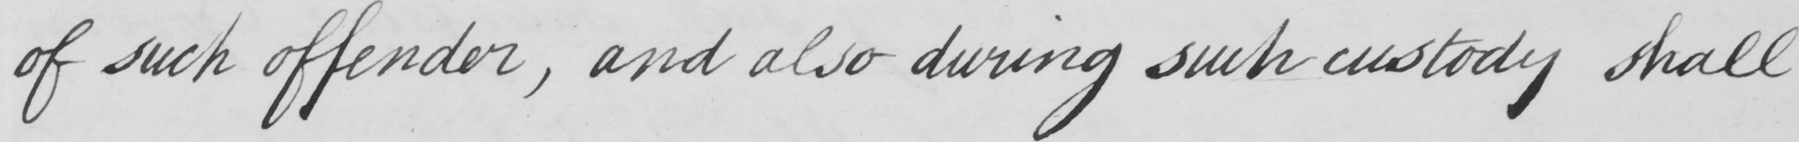What text is written in this handwritten line? of such offender , and also during such custody shall 